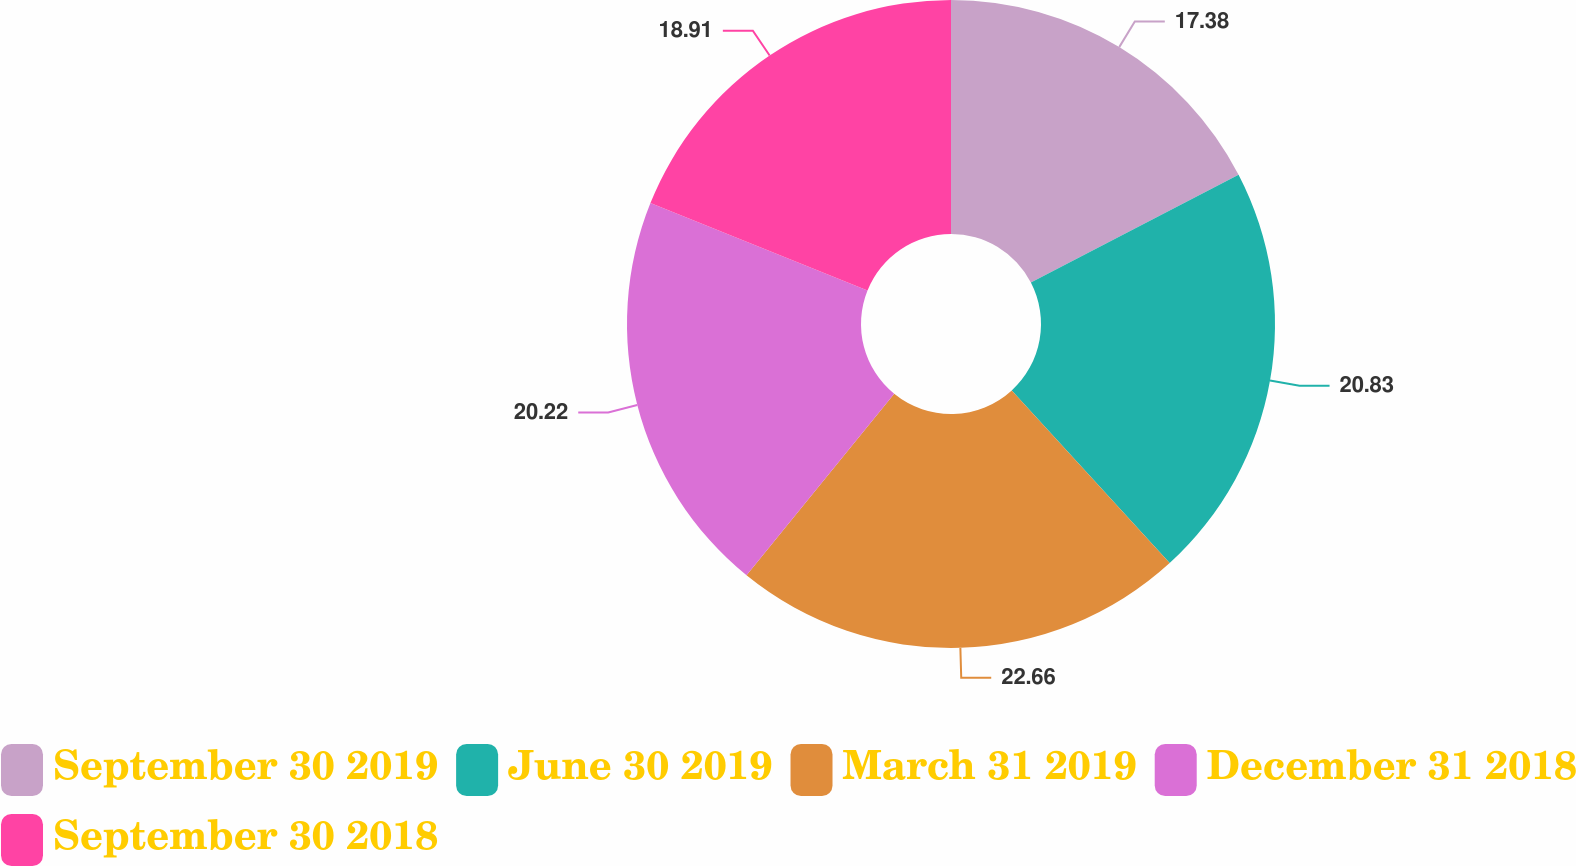Convert chart. <chart><loc_0><loc_0><loc_500><loc_500><pie_chart><fcel>September 30 2019<fcel>June 30 2019<fcel>March 31 2019<fcel>December 31 2018<fcel>September 30 2018<nl><fcel>17.38%<fcel>20.83%<fcel>22.66%<fcel>20.22%<fcel>18.91%<nl></chart> 